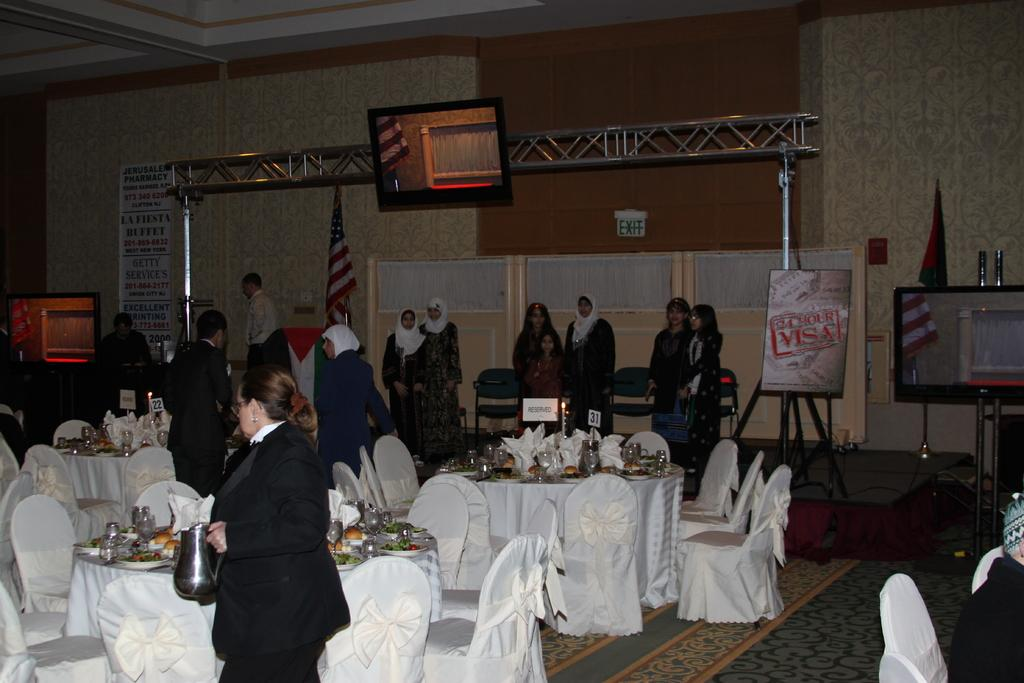How many people are in the image? There is a group of people in the image, but the exact number cannot be determined from the provided facts. What are the people near in the image? The people are standing near tables and chairs in the image. What can be seen on the tables? There are items placed on the tables in the image. What is hanging or displayed in the image? There is a banner visible in the image. What is used for displaying information or visuals in the image? There is a screen in the image. What type of structural elements can be seen in the image? There are rods in the image. What type of architectural feature is visible in the image? There is a wall visible in the image. What type of scissors are being used to cut the parcel in the image? There is no parcel or scissors present in the image, so this question cannot be answered. 